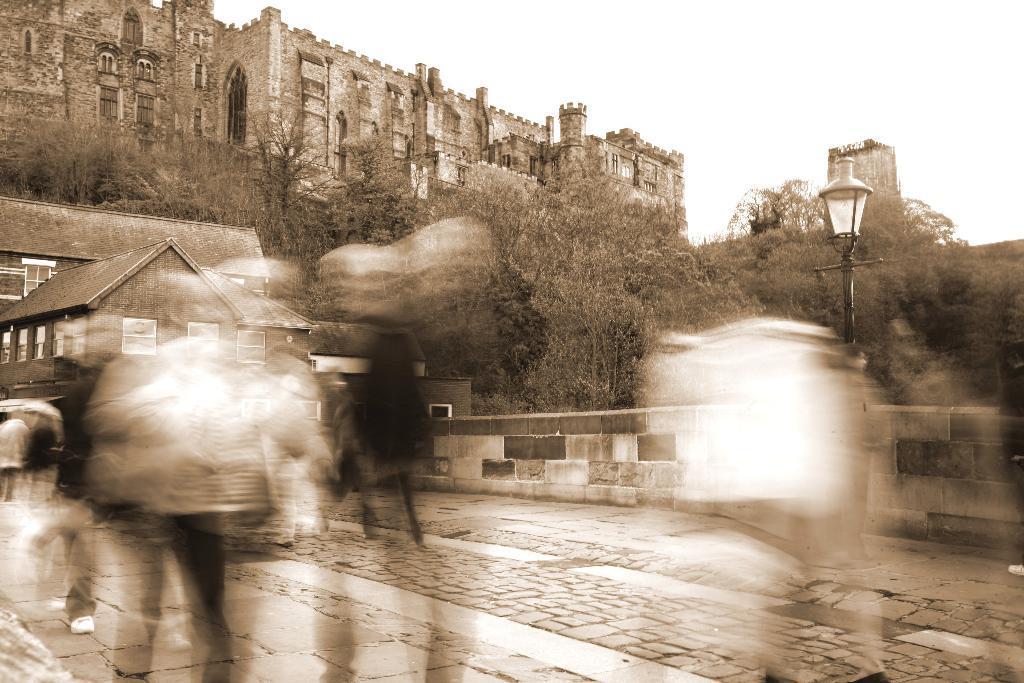Could you give a brief overview of what you see in this image? In this image we can see a fort a house, a pole and a light, there are some persons, and the front part of the image is blurred. 